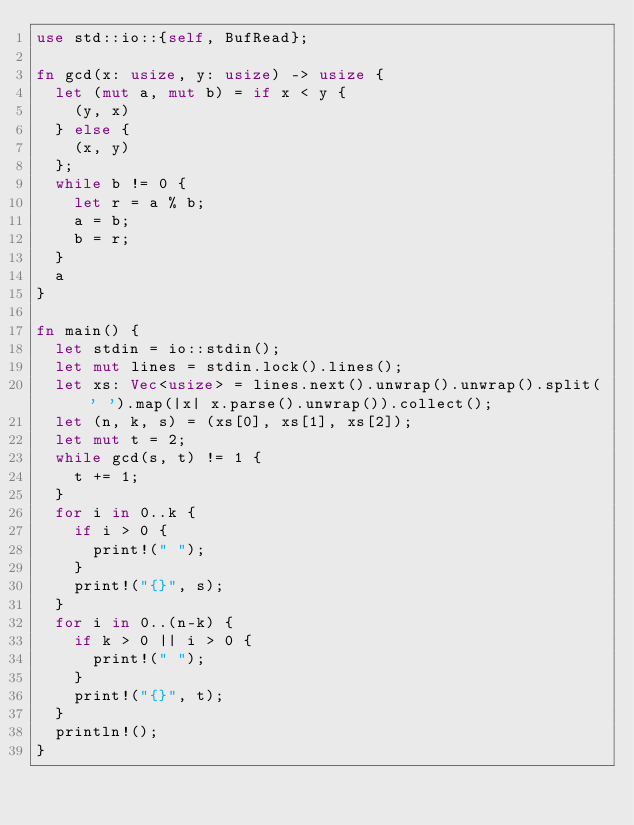<code> <loc_0><loc_0><loc_500><loc_500><_Rust_>use std::io::{self, BufRead};

fn gcd(x: usize, y: usize) -> usize {
  let (mut a, mut b) = if x < y {
    (y, x)
  } else {
    (x, y)
  };
  while b != 0 {
    let r = a % b;
    a = b;
    b = r;
  }
  a
}

fn main() {
  let stdin = io::stdin();
  let mut lines = stdin.lock().lines();
  let xs: Vec<usize> = lines.next().unwrap().unwrap().split(' ').map(|x| x.parse().unwrap()).collect();
  let (n, k, s) = (xs[0], xs[1], xs[2]);
  let mut t = 2;
  while gcd(s, t) != 1 {
    t += 1;
  }
  for i in 0..k {
    if i > 0 {
      print!(" ");
    }
    print!("{}", s);
  }
  for i in 0..(n-k) {
    if k > 0 || i > 0 {
      print!(" ");
    }
    print!("{}", t);
  }
  println!();
}</code> 